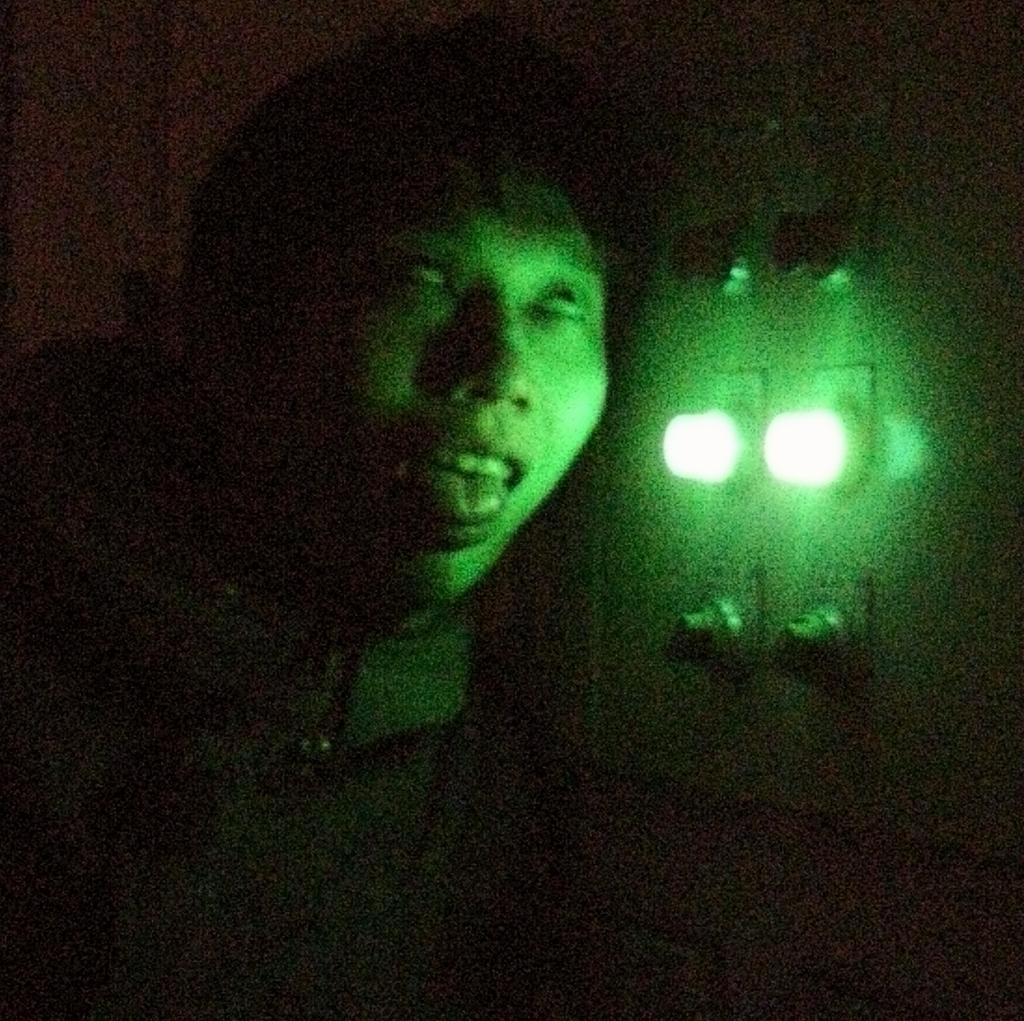Can you describe this image briefly? In this image I can see a person. Background I can see two lights in green color. 